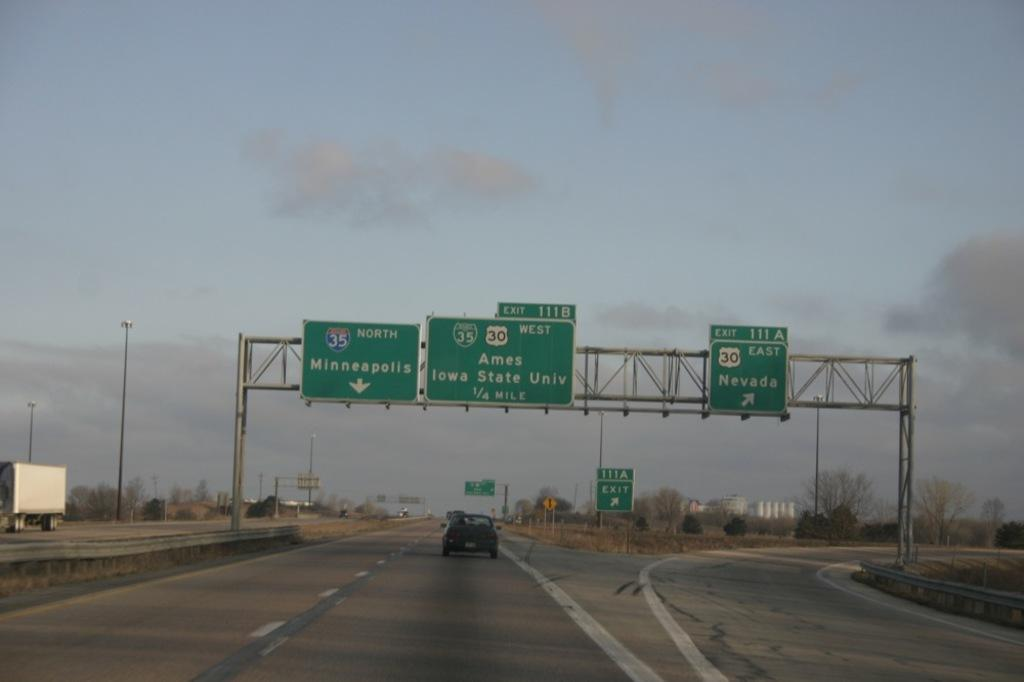<image>
Offer a succinct explanation of the picture presented. A freeway with one car passing under the signs 35  North Minneapolis, 35 30 West Ames Iowa State Univ 1/2 mile. 